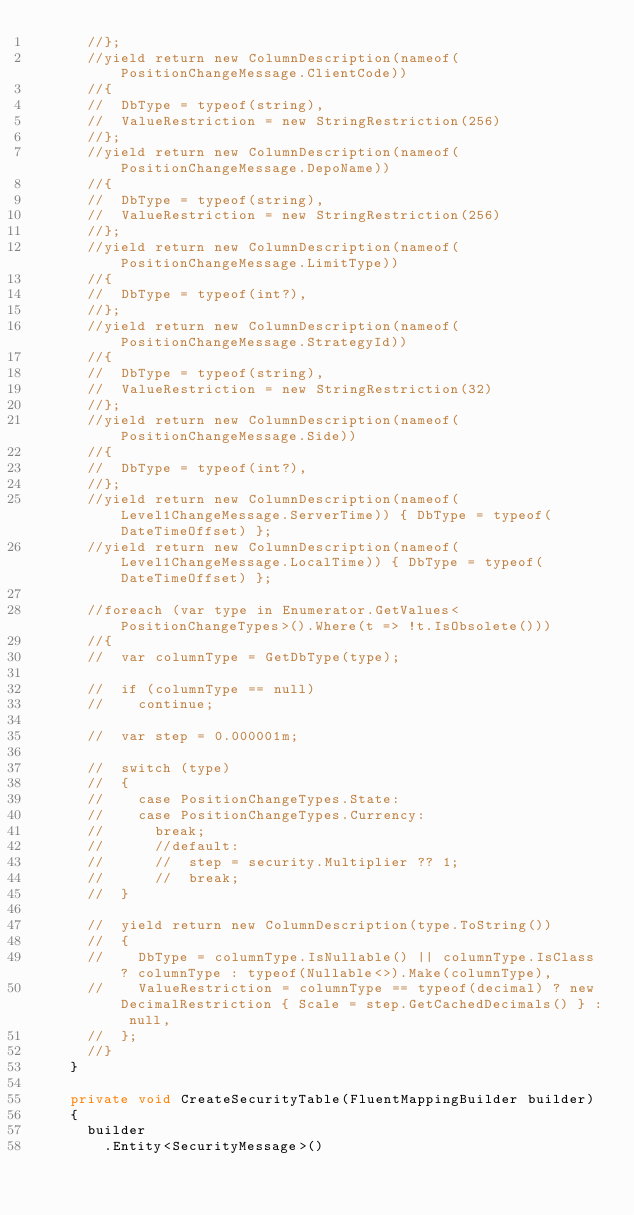Convert code to text. <code><loc_0><loc_0><loc_500><loc_500><_C#_>			//};
			//yield return new ColumnDescription(nameof(PositionChangeMessage.ClientCode))
			//{
			//	DbType = typeof(string),
			//	ValueRestriction = new StringRestriction(256)
			//};
			//yield return new ColumnDescription(nameof(PositionChangeMessage.DepoName))
			//{
			//	DbType = typeof(string),
			//	ValueRestriction = new StringRestriction(256)
			//};
			//yield return new ColumnDescription(nameof(PositionChangeMessage.LimitType))
			//{
			//	DbType = typeof(int?),
			//};
			//yield return new ColumnDescription(nameof(PositionChangeMessage.StrategyId))
			//{
			//	DbType = typeof(string),
			//	ValueRestriction = new StringRestriction(32)
			//};
			//yield return new ColumnDescription(nameof(PositionChangeMessage.Side))
			//{
			//	DbType = typeof(int?),
			//};
			//yield return new ColumnDescription(nameof(Level1ChangeMessage.ServerTime)) { DbType = typeof(DateTimeOffset) };
			//yield return new ColumnDescription(nameof(Level1ChangeMessage.LocalTime)) { DbType = typeof(DateTimeOffset) };

			//foreach (var type in Enumerator.GetValues<PositionChangeTypes>().Where(t => !t.IsObsolete()))
			//{
			//	var columnType = GetDbType(type);

			//	if (columnType == null)
			//		continue;

			//	var step = 0.000001m;

			//	switch (type)
			//	{
			//		case PositionChangeTypes.State:
			//		case PositionChangeTypes.Currency:
			//			break;
			//			//default:
			//			//	step = security.Multiplier ?? 1;
			//			//	break;
			//	}

			//	yield return new ColumnDescription(type.ToString())
			//	{
			//		DbType = columnType.IsNullable() || columnType.IsClass ? columnType : typeof(Nullable<>).Make(columnType),
			//		ValueRestriction = columnType == typeof(decimal) ? new DecimalRestriction { Scale = step.GetCachedDecimals() } : null,
			//	};
			//}
		}

		private void CreateSecurityTable(FluentMappingBuilder builder)
		{
			builder
				.Entity<SecurityMessage>()</code> 